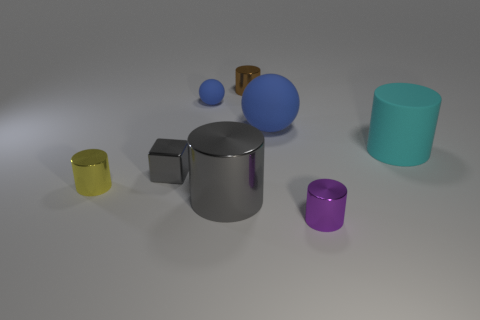Subtract all large cylinders. How many cylinders are left? 3 Subtract 5 cylinders. How many cylinders are left? 0 Add 1 blue matte balls. How many objects exist? 9 Subtract all yellow cylinders. How many cylinders are left? 4 Subtract all spheres. How many objects are left? 6 Add 5 big cyan shiny cylinders. How many big cyan shiny cylinders exist? 5 Subtract 1 yellow cylinders. How many objects are left? 7 Subtract all red spheres. Subtract all green blocks. How many spheres are left? 2 Subtract all gray blocks. How many purple cylinders are left? 1 Subtract all cylinders. Subtract all small purple matte things. How many objects are left? 3 